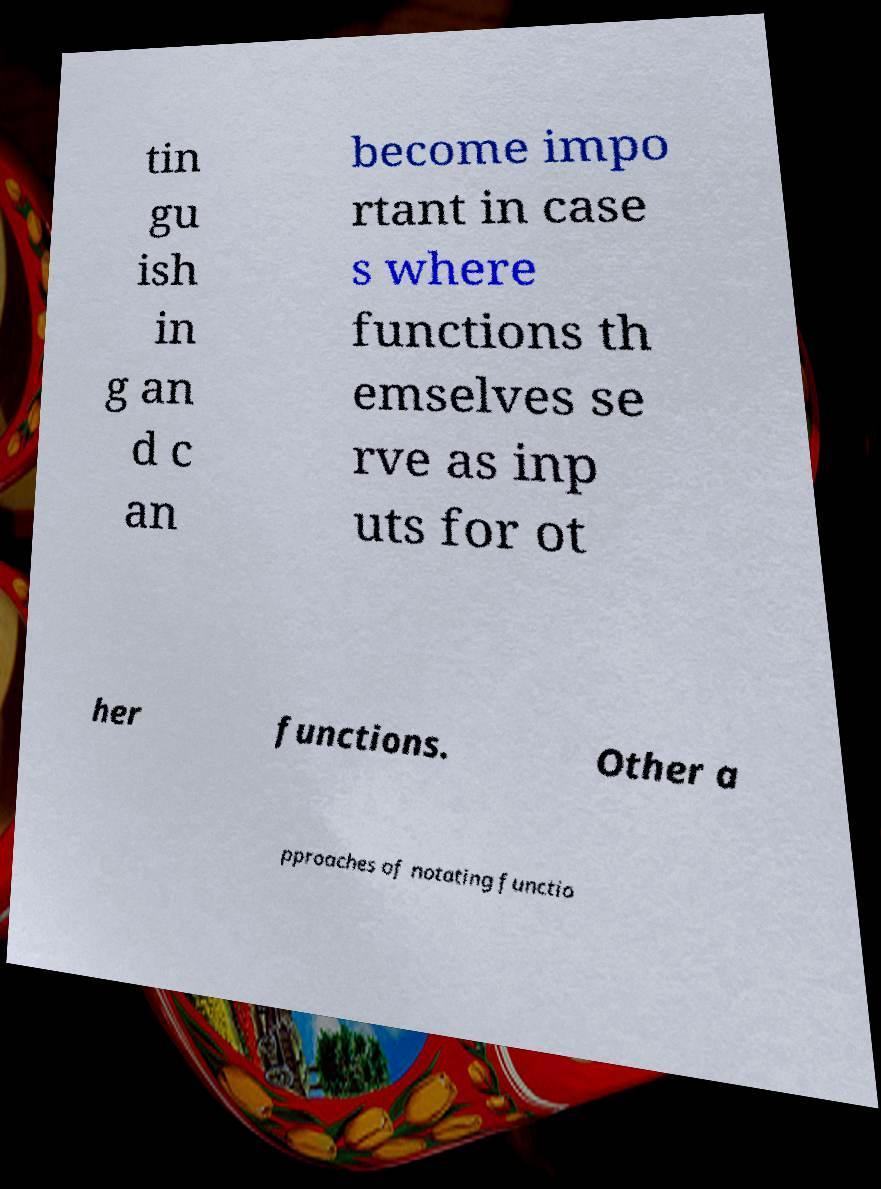Could you extract and type out the text from this image? tin gu ish in g an d c an become impo rtant in case s where functions th emselves se rve as inp uts for ot her functions. Other a pproaches of notating functio 